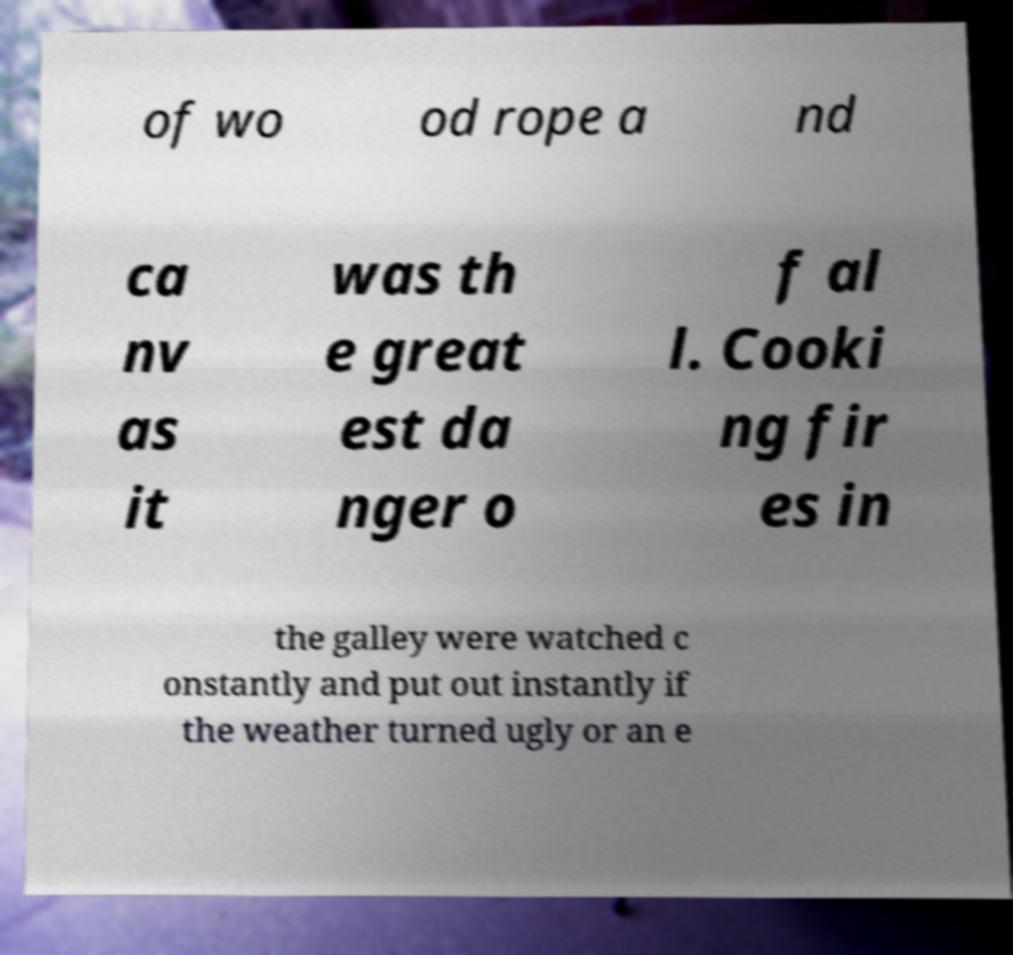Could you assist in decoding the text presented in this image and type it out clearly? of wo od rope a nd ca nv as it was th e great est da nger o f al l. Cooki ng fir es in the galley were watched c onstantly and put out instantly if the weather turned ugly or an e 